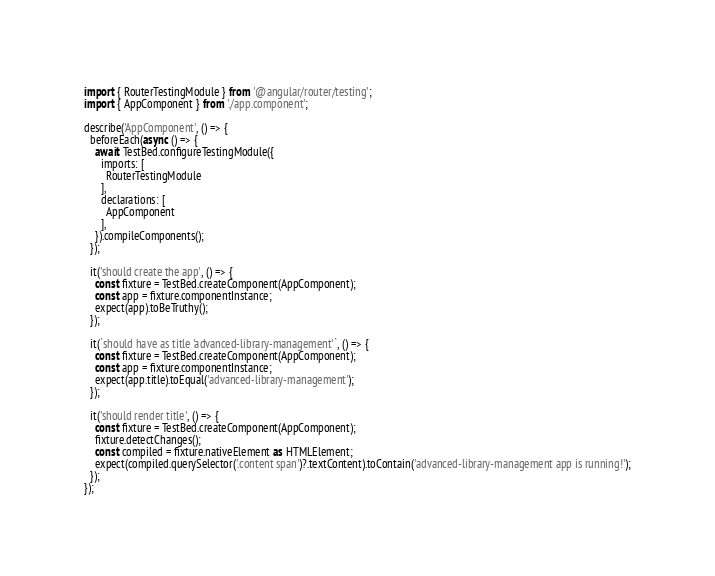Convert code to text. <code><loc_0><loc_0><loc_500><loc_500><_TypeScript_>import { RouterTestingModule } from '@angular/router/testing';
import { AppComponent } from './app.component';

describe('AppComponent', () => {
  beforeEach(async () => {
    await TestBed.configureTestingModule({
      imports: [
        RouterTestingModule
      ],
      declarations: [
        AppComponent
      ],
    }).compileComponents();
  });

  it('should create the app', () => {
    const fixture = TestBed.createComponent(AppComponent);
    const app = fixture.componentInstance;
    expect(app).toBeTruthy();
  });

  it(`should have as title 'advanced-library-management'`, () => {
    const fixture = TestBed.createComponent(AppComponent);
    const app = fixture.componentInstance;
    expect(app.title).toEqual('advanced-library-management');
  });

  it('should render title', () => {
    const fixture = TestBed.createComponent(AppComponent);
    fixture.detectChanges();
    const compiled = fixture.nativeElement as HTMLElement;
    expect(compiled.querySelector('.content span')?.textContent).toContain('advanced-library-management app is running!');
  });
});
</code> 